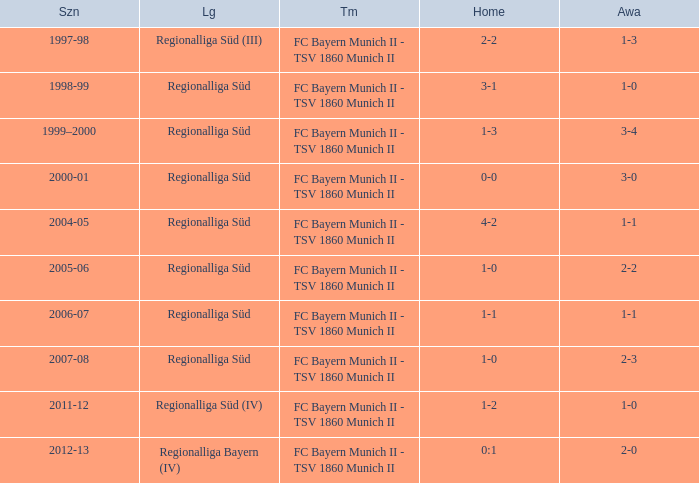Could you parse the entire table? {'header': ['Szn', 'Lg', 'Tm', 'Home', 'Awa'], 'rows': [['1997-98', 'Regionalliga Süd (III)', 'FC Bayern Munich II - TSV 1860 Munich II', '2-2', '1-3'], ['1998-99', 'Regionalliga Süd', 'FC Bayern Munich II - TSV 1860 Munich II', '3-1', '1-0'], ['1999–2000', 'Regionalliga Süd', 'FC Bayern Munich II - TSV 1860 Munich II', '1-3', '3-4'], ['2000-01', 'Regionalliga Süd', 'FC Bayern Munich II - TSV 1860 Munich II', '0-0', '3-0'], ['2004-05', 'Regionalliga Süd', 'FC Bayern Munich II - TSV 1860 Munich II', '4-2', '1-1'], ['2005-06', 'Regionalliga Süd', 'FC Bayern Munich II - TSV 1860 Munich II', '1-0', '2-2'], ['2006-07', 'Regionalliga Süd', 'FC Bayern Munich II - TSV 1860 Munich II', '1-1', '1-1'], ['2007-08', 'Regionalliga Süd', 'FC Bayern Munich II - TSV 1860 Munich II', '1-0', '2-3'], ['2011-12', 'Regionalliga Süd (IV)', 'FC Bayern Munich II - TSV 1860 Munich II', '1-2', '1-0'], ['2012-13', 'Regionalliga Bayern (IV)', 'FC Bayern Munich II - TSV 1860 Munich II', '0:1', '2-0']]} Which season has the regionalliga süd (iii) league? 1997-98. 